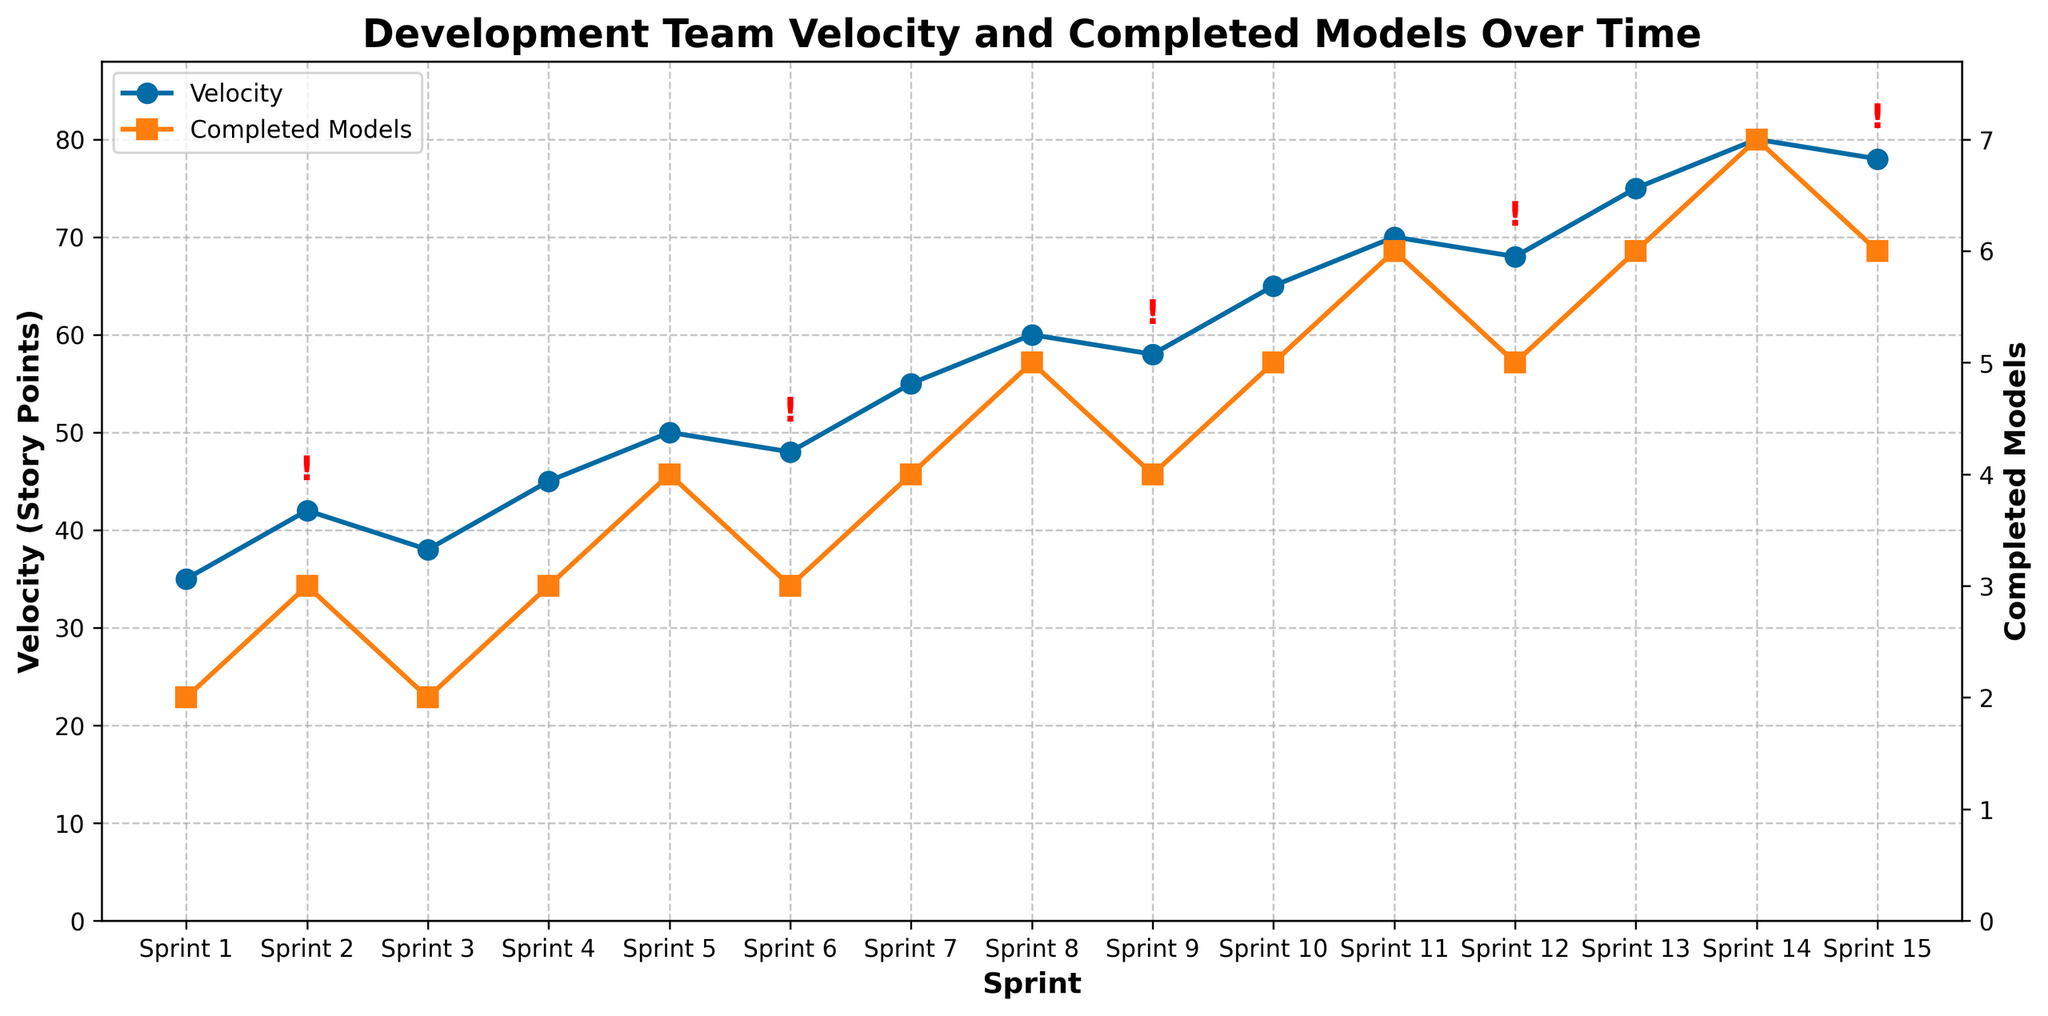What is the trend of the team's velocity over time? The velocity, represented by the blue line with circle markers, generally increases over the sprints, starting from 35 story points in Sprint 1 and reaching a peak of 80 story points by Sprint 14.
Answer: Increasing Between which two sprints did the team's velocity increase the most? The velocity increased the most between Sprint 14 (80 story points) and Sprint 15 (78 story points), resulting in a change of -2 story points.
Answer: Sprint 14 and Sprint 15 How many completed models were delivered when the velocity reached its maximum? The maximum velocity is observed in Sprint 14 at 80 story points. At this point, the number of completed models is 7, indicated by the orange square marker.
Answer: 7 models Was there any sprint where the velocity decreased compared to the previous sprint? If so, which sprint? Yes, the velocity decreased between Sprint 14 (80 story points) and Sprint 15 (78 story points), as shown by the drop in the blue line between these two sprints.
Answer: Sprint 15 How many times do we see a major blocker affecting the velocity, and what is the impact on the velocity in those cases? Major blockers are indicated by red '!' annotations. They are present in Sprint 2, Sprint 6, Sprint 9, Sprint 12, and Sprint 15. The impact on velocity varies, but it generally results in smaller increases or decreases in velocity compared to other sprints. For instance, Sprint 2 has only a slight increase, and Sprint 6 sees a small decrease.
Answer: 5 times What is the average number of completed models per sprint? Sum the number of completed models for each sprint: (2 + 3 + 2 + 3 + 4 + 3 + 4 + 5 + 4 + 5 + 6 + 5 + 6 + 7 + 6) = 65, and divide by the number of sprints (15): 65/15 = 4.33.
Answer: 4.33 models Compare the velocity and the number of completed models in Sprint 3 and Sprint 6. What do you observe? In Sprint 3, the velocity is 38 story points with 2 completed models. In Sprint 6, the velocity is higher at 48 story points, but with only 3 completed models. Despite the increased velocity, the number of completed models did not increase as significantly, potentially due to a major blocker.
Answer: Higher velocity with similar model completion Which sprint shows the highest number of completed models, and how does this correlate with the velocity? Sprint 14 shows the highest number of completed models at 7, with a corresponding high velocity of 80 story points. This indicates that both velocity and completed models peaked together in this sprint.
Answer: Sprint 14 What is the relationship between team size and velocity over sprints? Generally, as the team size increases, the velocity also shows an increasing trend. For example, from Sprint 4 (team size 7, velocity 45) to Sprint 10 (team size 9, velocity 65), both metrics show a rising pattern, suggesting a positive correlation.
Answer: Positive correlation 